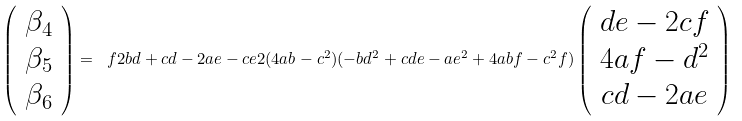<formula> <loc_0><loc_0><loc_500><loc_500>\left ( \begin{array} { c } \beta _ { 4 } \\ \beta _ { 5 } \\ \beta _ { 6 } \end{array} \right ) = \ f { 2 b d + c d - 2 a e - c e } { 2 ( 4 a b - c ^ { 2 } ) ( - b d ^ { 2 } + c d e - a e ^ { 2 } + 4 a b f - c ^ { 2 } f ) } \left ( \begin{array} { c } d e - 2 c f \\ 4 a f - d ^ { 2 } \\ c d - 2 a e \end{array} \right )</formula> 